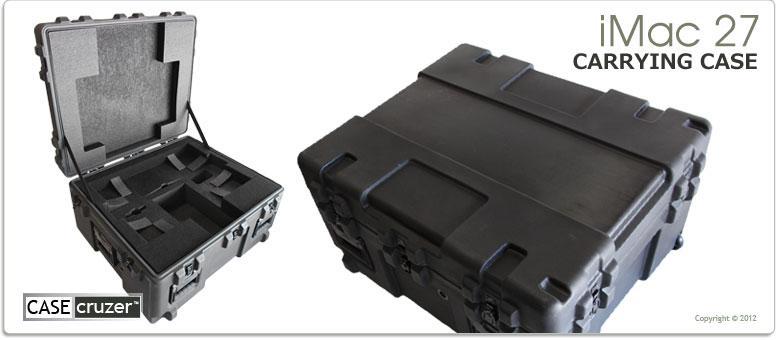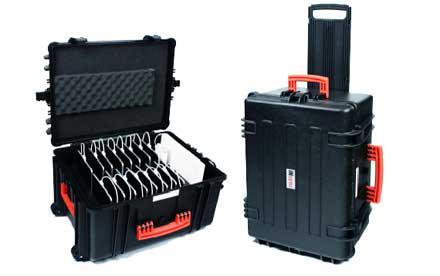The first image is the image on the left, the second image is the image on the right. Analyze the images presented: Is the assertion "One of the cases shown is closed, standing upright, and has a handle sticking out of the top for pushing or pulling the case." valid? Answer yes or no. Yes. The first image is the image on the left, the second image is the image on the right. Evaluate the accuracy of this statement regarding the images: "A carrying case stands upright and closed with another case in one of the images.". Is it true? Answer yes or no. Yes. 